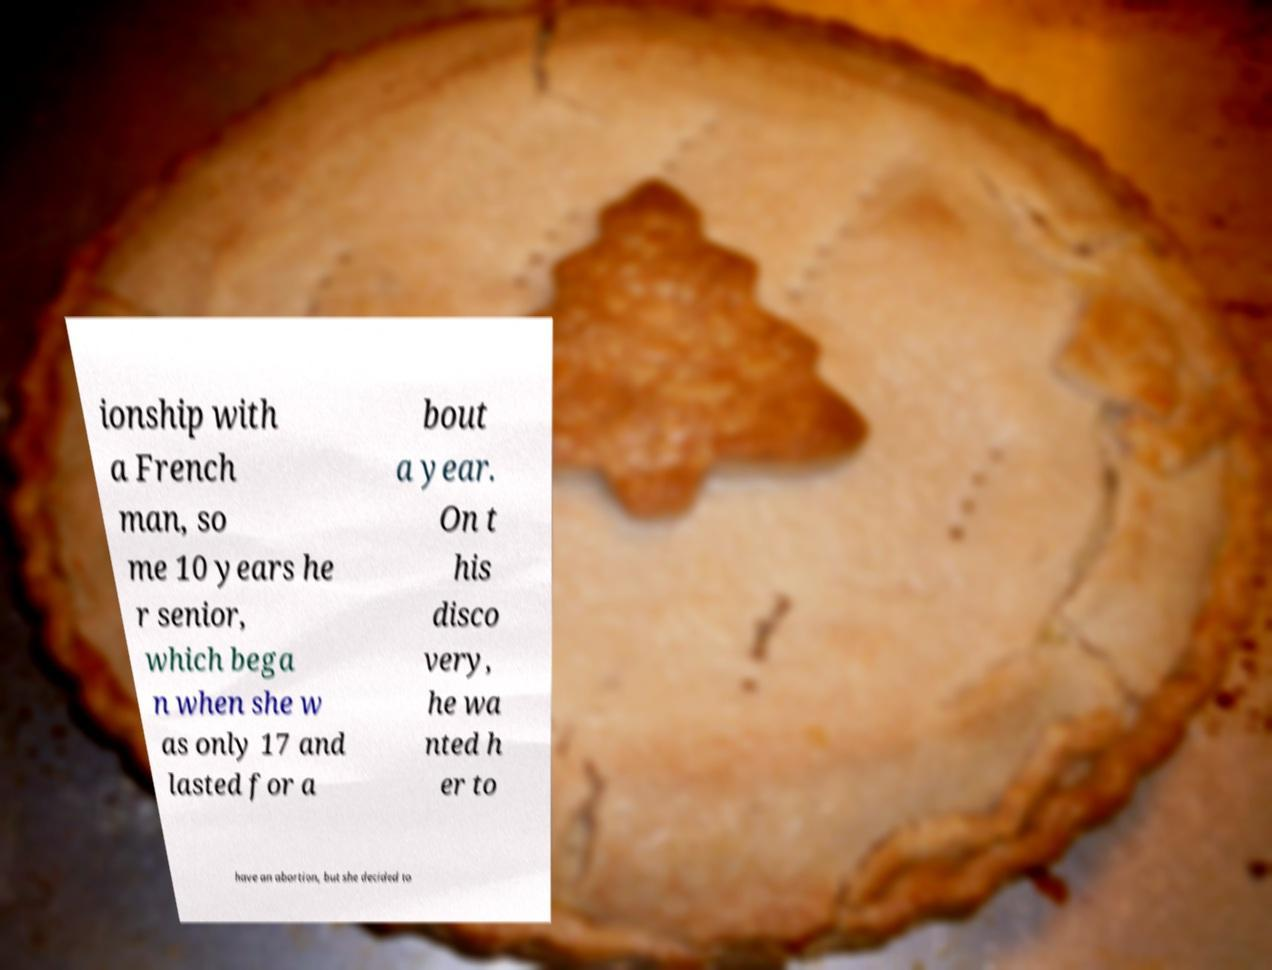Can you accurately transcribe the text from the provided image for me? ionship with a French man, so me 10 years he r senior, which bega n when she w as only 17 and lasted for a bout a year. On t his disco very, he wa nted h er to have an abortion, but she decided to 